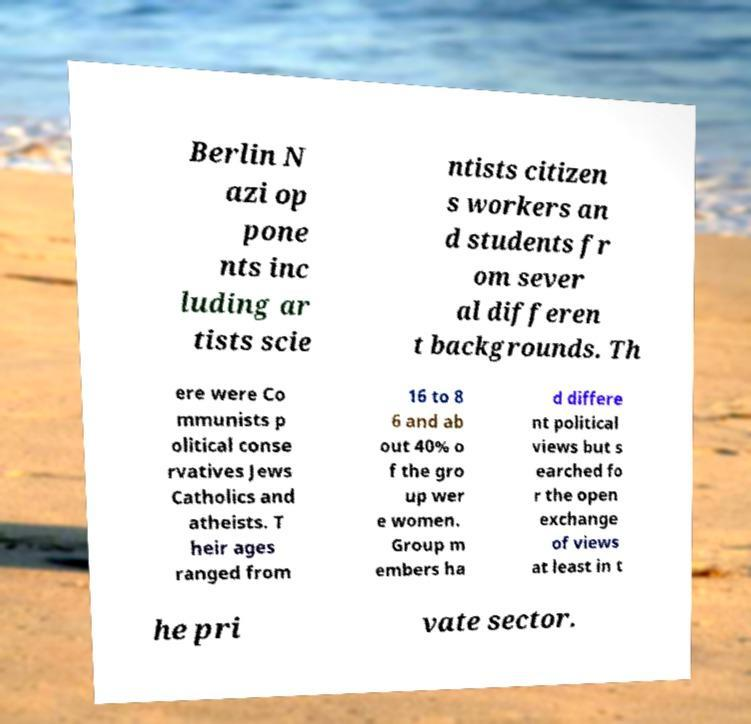What messages or text are displayed in this image? I need them in a readable, typed format. Berlin N azi op pone nts inc luding ar tists scie ntists citizen s workers an d students fr om sever al differen t backgrounds. Th ere were Co mmunists p olitical conse rvatives Jews Catholics and atheists. T heir ages ranged from 16 to 8 6 and ab out 40% o f the gro up wer e women. Group m embers ha d differe nt political views but s earched fo r the open exchange of views at least in t he pri vate sector. 